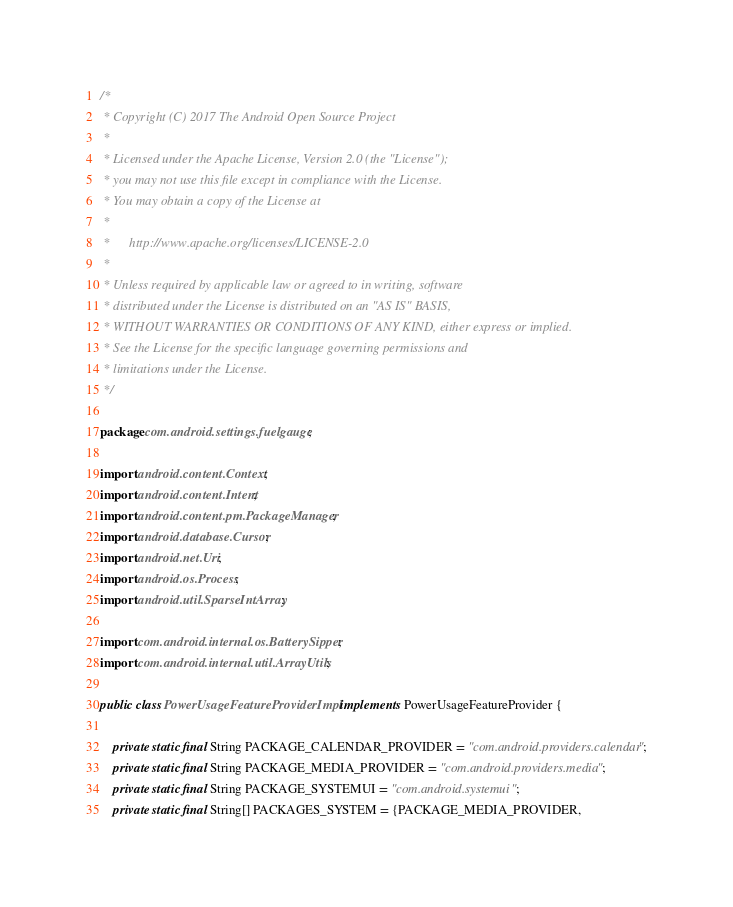Convert code to text. <code><loc_0><loc_0><loc_500><loc_500><_Java_>/*
 * Copyright (C) 2017 The Android Open Source Project
 *
 * Licensed under the Apache License, Version 2.0 (the "License");
 * you may not use this file except in compliance with the License.
 * You may obtain a copy of the License at
 *
 *      http://www.apache.org/licenses/LICENSE-2.0
 *
 * Unless required by applicable law or agreed to in writing, software
 * distributed under the License is distributed on an "AS IS" BASIS,
 * WITHOUT WARRANTIES OR CONDITIONS OF ANY KIND, either express or implied.
 * See the License for the specific language governing permissions and
 * limitations under the License.
 */

package com.android.settings.fuelgauge;

import android.content.Context;
import android.content.Intent;
import android.content.pm.PackageManager;
import android.database.Cursor;
import android.net.Uri;
import android.os.Process;
import android.util.SparseIntArray;

import com.android.internal.os.BatterySipper;
import com.android.internal.util.ArrayUtils;

public class PowerUsageFeatureProviderImpl implements PowerUsageFeatureProvider {

    private static final String PACKAGE_CALENDAR_PROVIDER = "com.android.providers.calendar";
    private static final String PACKAGE_MEDIA_PROVIDER = "com.android.providers.media";
    private static final String PACKAGE_SYSTEMUI = "com.android.systemui";
    private static final String[] PACKAGES_SYSTEM = {PACKAGE_MEDIA_PROVIDER,</code> 